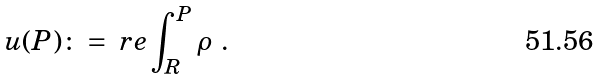<formula> <loc_0><loc_0><loc_500><loc_500>u ( P ) \colon = \ r e \int _ { R } ^ { P } \rho \ .</formula> 